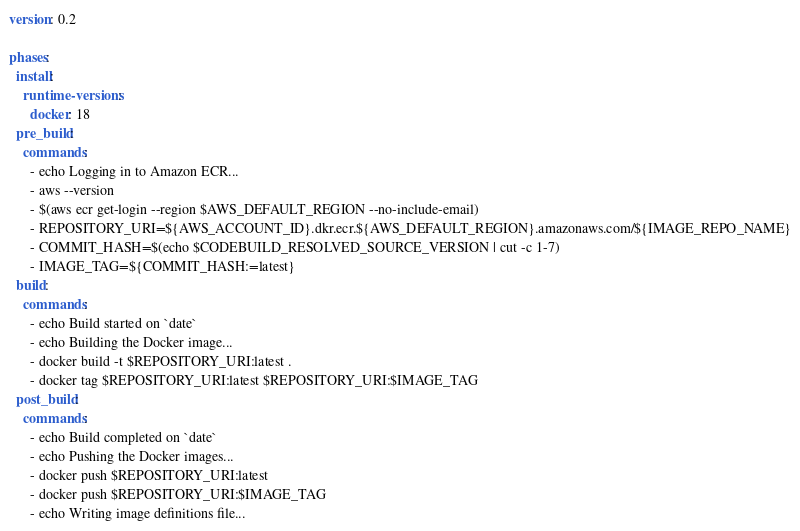<code> <loc_0><loc_0><loc_500><loc_500><_YAML_>version: 0.2

phases:
  install:
    runtime-versions:
      docker: 18
  pre_build:
    commands:
      - echo Logging in to Amazon ECR...
      - aws --version
      - $(aws ecr get-login --region $AWS_DEFAULT_REGION --no-include-email)
      - REPOSITORY_URI=${AWS_ACCOUNT_ID}.dkr.ecr.${AWS_DEFAULT_REGION}.amazonaws.com/${IMAGE_REPO_NAME}
      - COMMIT_HASH=$(echo $CODEBUILD_RESOLVED_SOURCE_VERSION | cut -c 1-7)
      - IMAGE_TAG=${COMMIT_HASH:=latest}
  build:
    commands:
      - echo Build started on `date`
      - echo Building the Docker image...
      - docker build -t $REPOSITORY_URI:latest .
      - docker tag $REPOSITORY_URI:latest $REPOSITORY_URI:$IMAGE_TAG
  post_build:
    commands:
      - echo Build completed on `date`
      - echo Pushing the Docker images...
      - docker push $REPOSITORY_URI:latest
      - docker push $REPOSITORY_URI:$IMAGE_TAG
      - echo Writing image definitions file...
</code> 